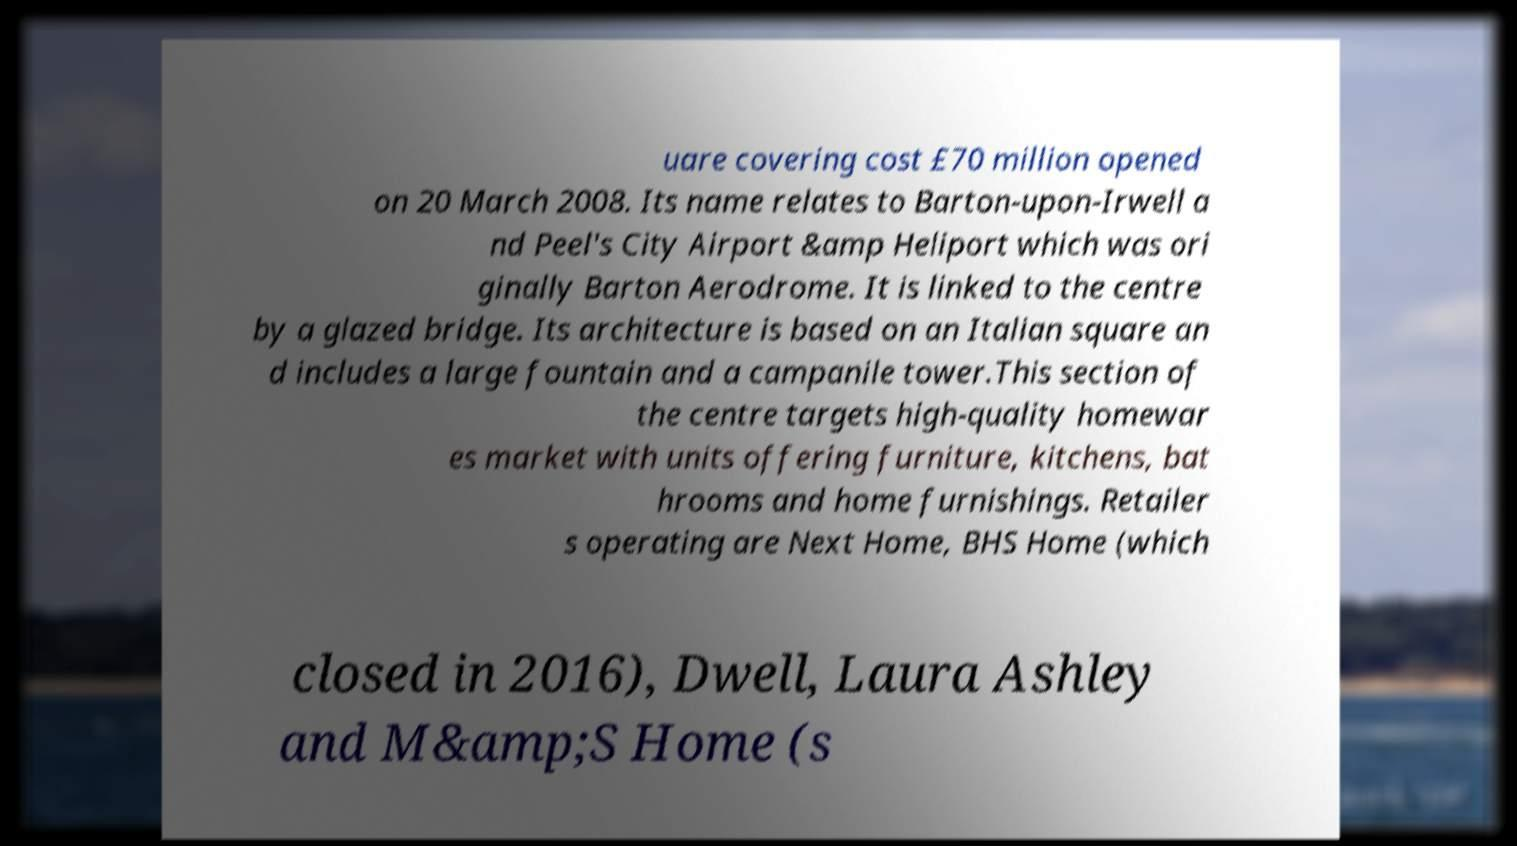There's text embedded in this image that I need extracted. Can you transcribe it verbatim? uare covering cost £70 million opened on 20 March 2008. Its name relates to Barton-upon-Irwell a nd Peel's City Airport &amp Heliport which was ori ginally Barton Aerodrome. It is linked to the centre by a glazed bridge. Its architecture is based on an Italian square an d includes a large fountain and a campanile tower.This section of the centre targets high-quality homewar es market with units offering furniture, kitchens, bat hrooms and home furnishings. Retailer s operating are Next Home, BHS Home (which closed in 2016), Dwell, Laura Ashley and M&amp;S Home (s 